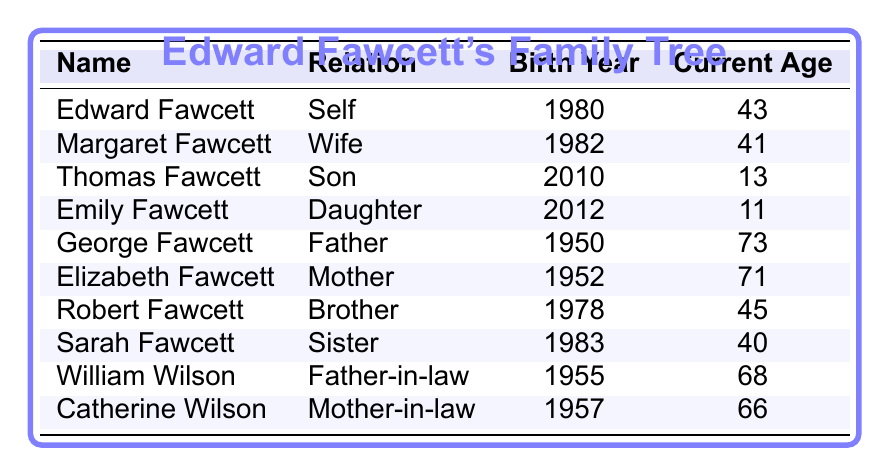What is Edward Fawcett's birth year? By looking at the table, Edward Fawcett's birth year is listed directly in the corresponding row under "Birth Year."
Answer: 1980 How old is Thomas Fawcett? According to the table, Thomas Fawcett's current age is provided in the row marked as "Son."
Answer: 13 Who is the youngest member of Edward Fawcett's family? To determine the youngest family member, we compare the ages of all members. Emily Fawcett is 11, which is younger than Thomas and all other members.
Answer: Emily Fawcett What is the age difference between Edward and his brother Robert? Edward Fawcett is 43 years old and Robert Fawcett is 45. The age difference can be found by subtracting Edward’s age from Robert’s age: 45 - 43 = 2.
Answer: 2 How old are Edward’s parents combined? The current ages of Edward's parents are George Fawcett (73) and Elizabeth Fawcett (71). Adding their ages gives: 73 + 71 = 144.
Answer: 144 Is Sarah Fawcett older than Margaret Fawcett? Sarah Fawcett is 40 years old, while Margaret is 41. We can see that Margaret is older by checking their individual ages in the table.
Answer: No Who is the oldest family member? The oldest is George Fawcett, who is 73 years old. This can be confirmed by reviewing the ages in the table.
Answer: George Fawcett What is the average age of Edward Fawcett's children? Edward has two children: Thomas (13) and Emily (11). To find the average, we sum their ages: 13 + 11 = 24, then divide by 2 (the number of children): 24 / 2 = 12.
Answer: 12 How many family members are older than William Wilson? William Wilson is 68 years old. Looking through the ages, George Fawcett (73) and Elizabeth Fawcett (71) are older. So, there are two family members older than him.
Answer: 2 Is there a sibling of Edward who has a birth year before him? Robert Fawcett, Edward's brother, was born in 1978, which is before Edward's birth year (1980). This statement is true based on their listed birth years.
Answer: Yes 